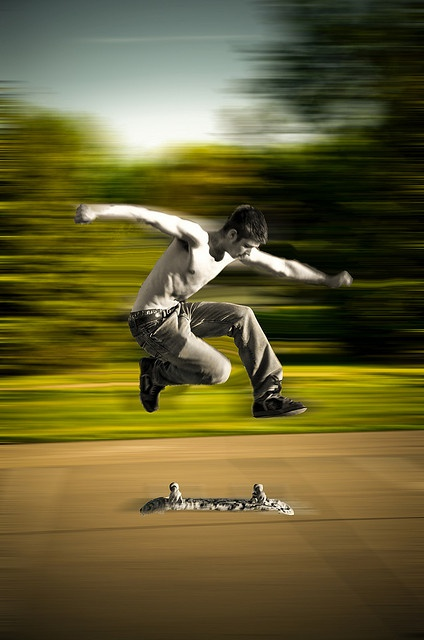Describe the objects in this image and their specific colors. I can see people in black, ivory, gray, and darkgreen tones and skateboard in black, tan, gray, and olive tones in this image. 